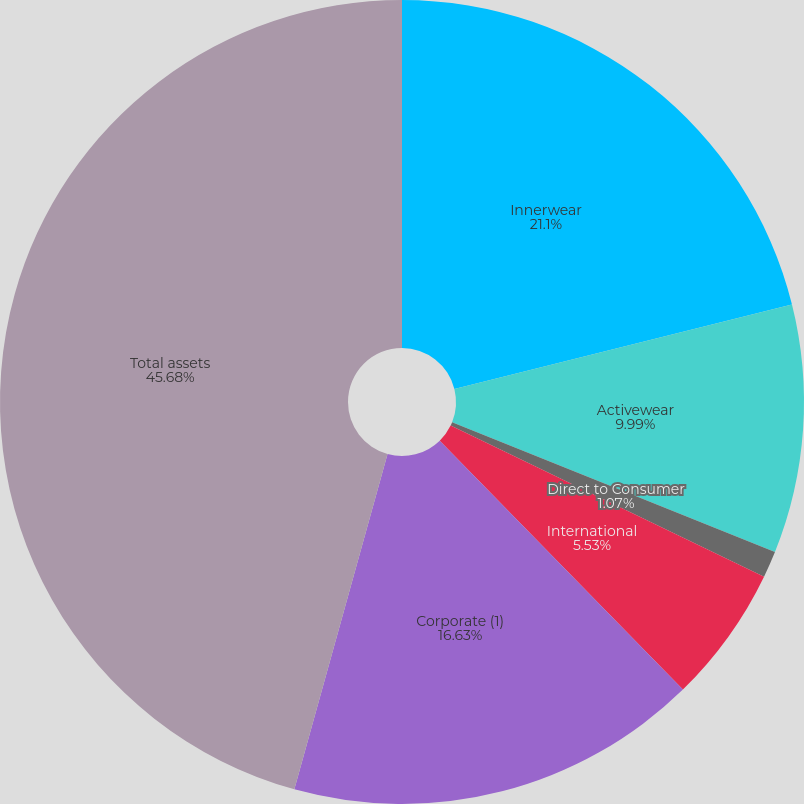Convert chart. <chart><loc_0><loc_0><loc_500><loc_500><pie_chart><fcel>Innerwear<fcel>Activewear<fcel>Direct to Consumer<fcel>International<fcel>Corporate (1)<fcel>Total assets<nl><fcel>21.1%<fcel>9.99%<fcel>1.07%<fcel>5.53%<fcel>16.63%<fcel>45.69%<nl></chart> 